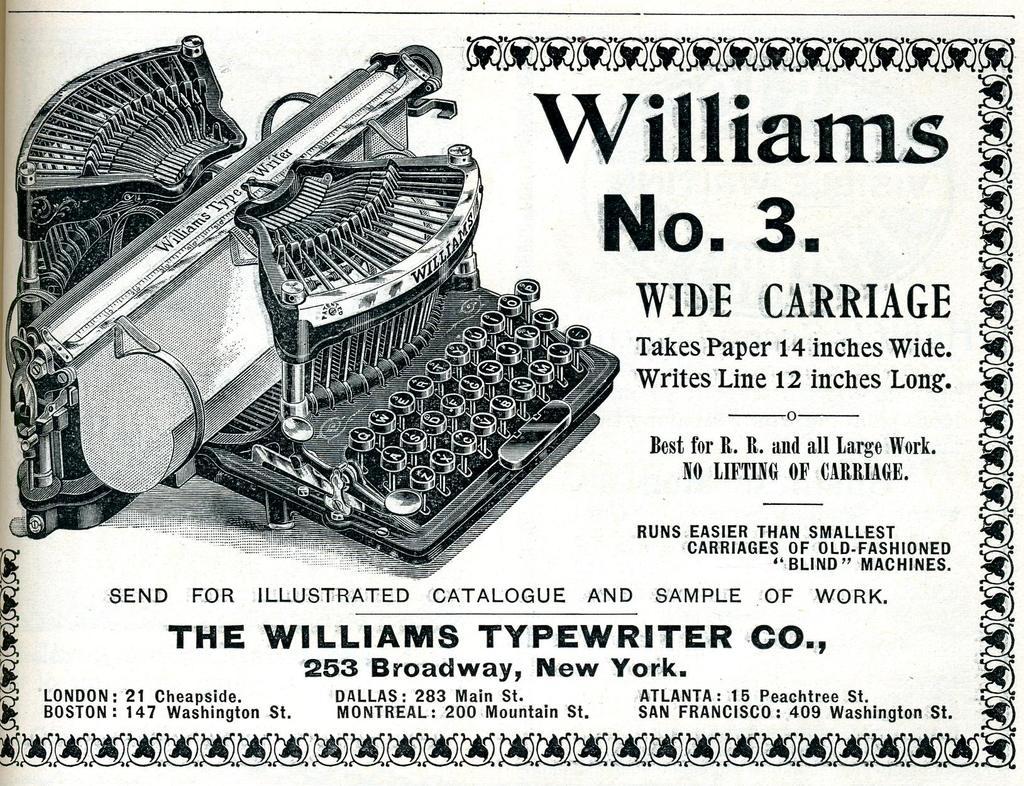What city is the typewriter company in?
Keep it short and to the point. New york. What company is this advertising?
Your response must be concise. Williams. 